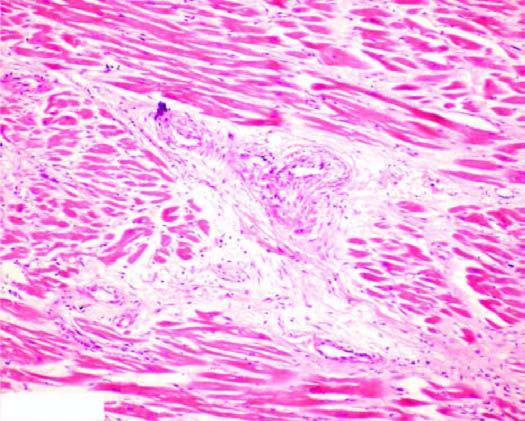what is there, especially around small blood vessels in the interstitium?
Answer the question using a single word or phrase. Patchy myocardial fibrosis 